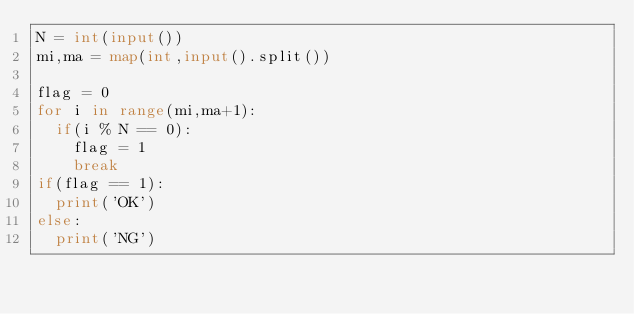<code> <loc_0><loc_0><loc_500><loc_500><_Python_>N = int(input())
mi,ma = map(int,input().split())

flag = 0
for i in range(mi,ma+1):
  if(i % N == 0):
    flag = 1
    break
if(flag == 1):
  print('OK')
else:
  print('NG')</code> 